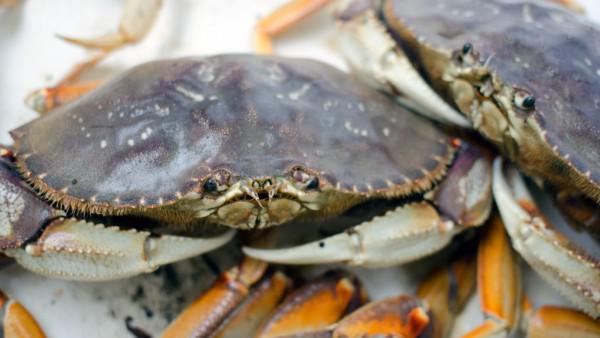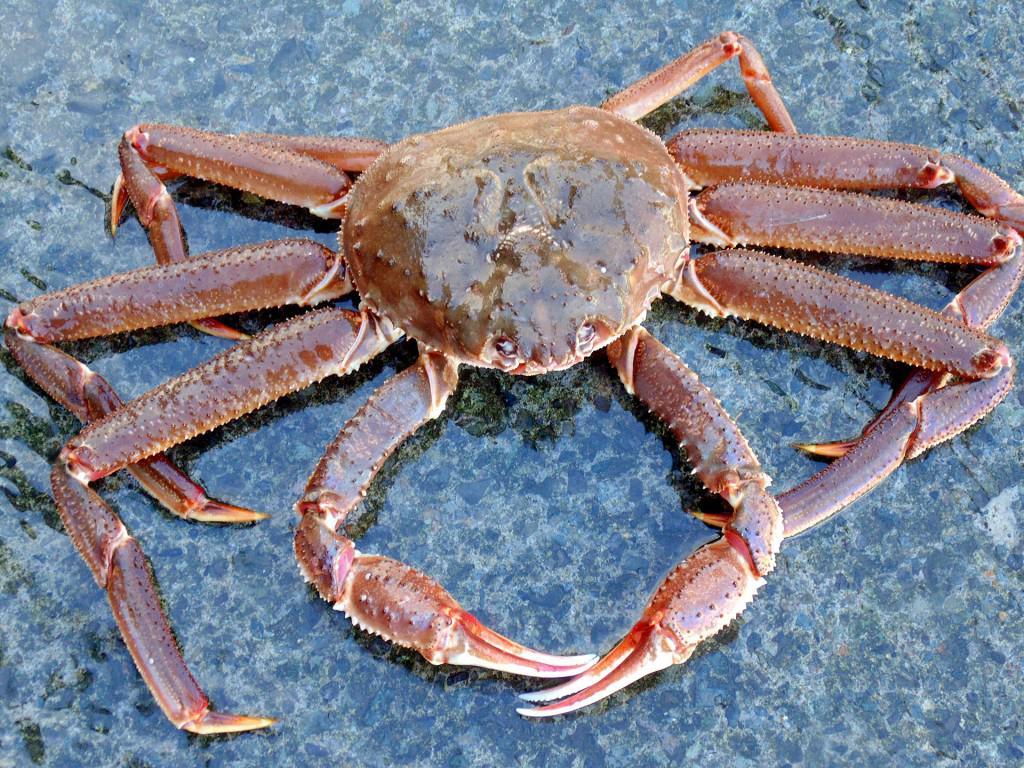The first image is the image on the left, the second image is the image on the right. Assess this claim about the two images: "Two hands are holding the crab in the left image.". Correct or not? Answer yes or no. No. The first image is the image on the left, the second image is the image on the right. Considering the images on both sides, is "A person is touching the crab in the image on the left." valid? Answer yes or no. No. 